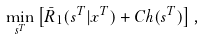Convert formula to latex. <formula><loc_0><loc_0><loc_500><loc_500>\min _ { s ^ { T } } \left [ \bar { R } _ { 1 } ( s ^ { T } | x ^ { T } ) + C h ( s ^ { T } ) \right ] ,</formula> 